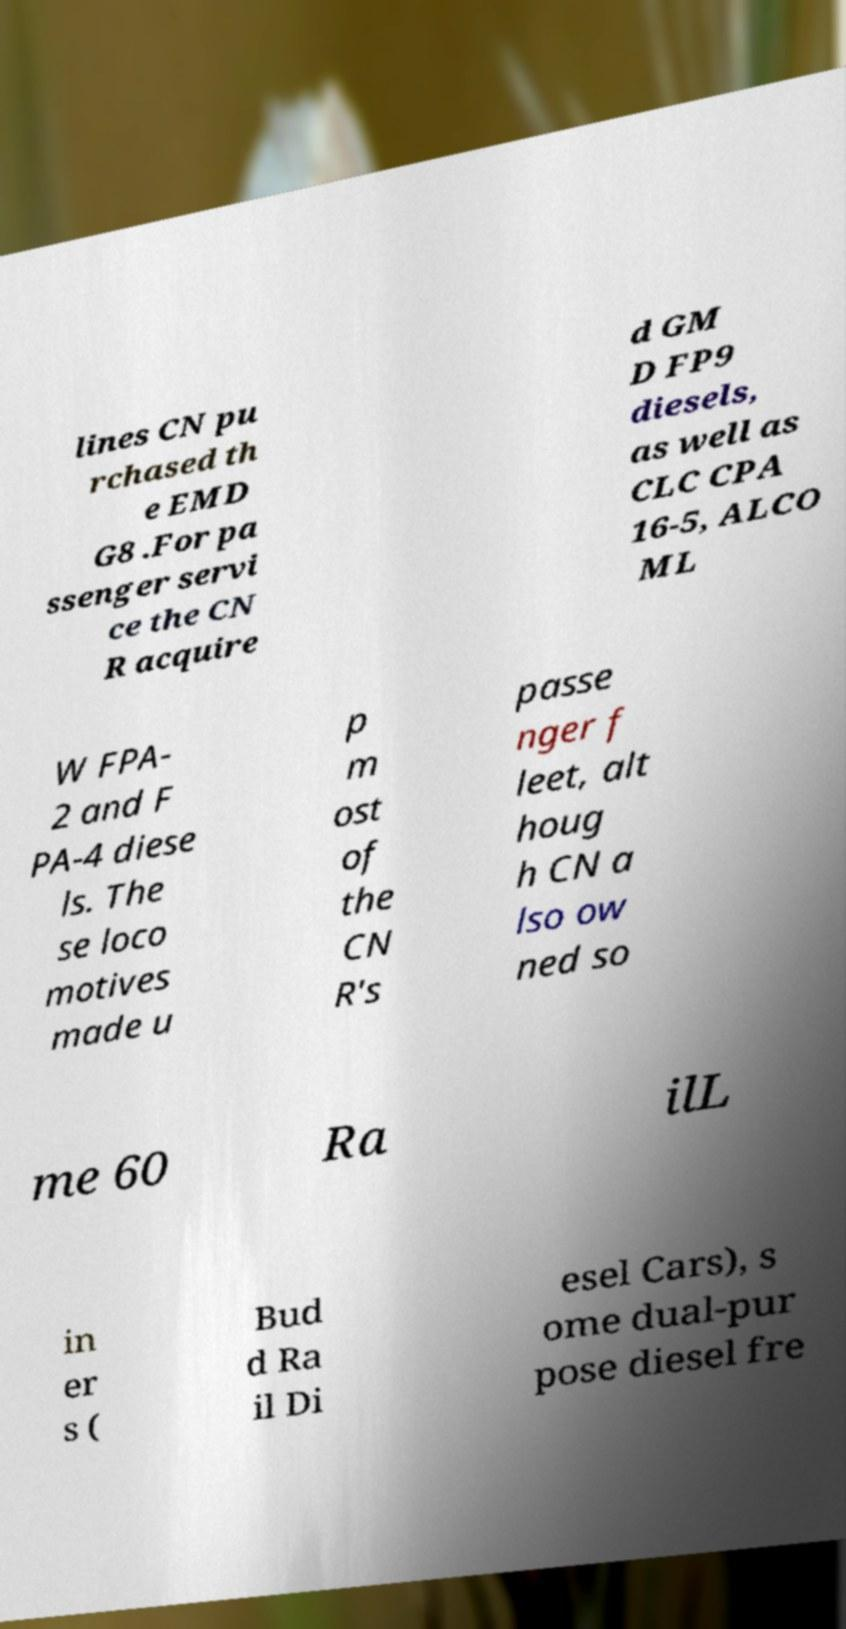I need the written content from this picture converted into text. Can you do that? lines CN pu rchased th e EMD G8 .For pa ssenger servi ce the CN R acquire d GM D FP9 diesels, as well as CLC CPA 16-5, ALCO ML W FPA- 2 and F PA-4 diese ls. The se loco motives made u p m ost of the CN R's passe nger f leet, alt houg h CN a lso ow ned so me 60 Ra ilL in er s ( Bud d Ra il Di esel Cars), s ome dual-pur pose diesel fre 